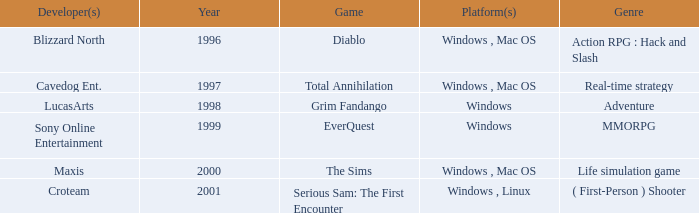What game in the genre of adventure, has a windows platform and its year is after 1997? Grim Fandango. 